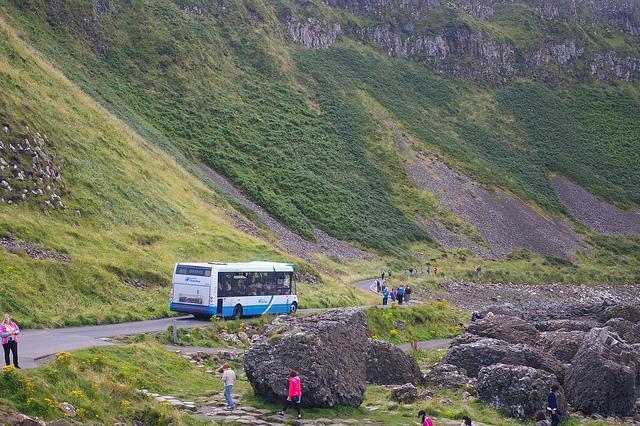What act of nature could potentially physically impede progress on the road?
Indicate the correct response by choosing from the four available options to answer the question.
Options: Pandemic, flood, landslide, lightning. Landslide. 